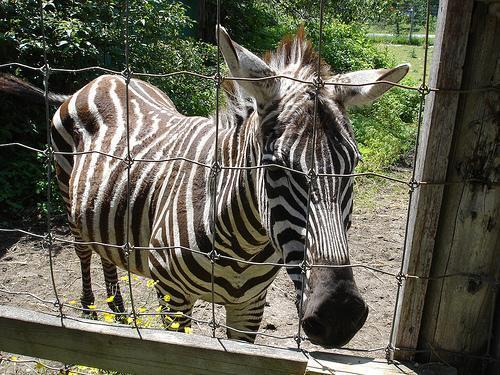How many people are in the picture?
Give a very brief answer. 0. 